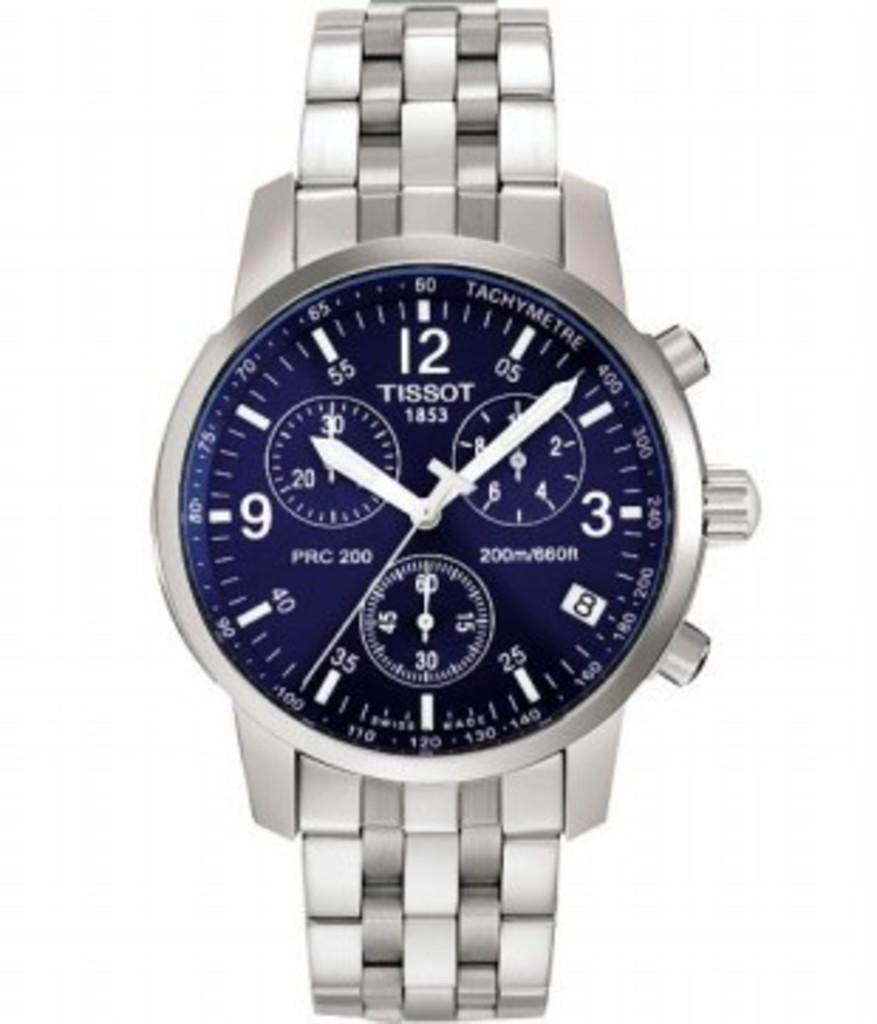Provide a one-sentence caption for the provided image. silver Tissot 1853 watch that has 3 smaller gauges on it also. 